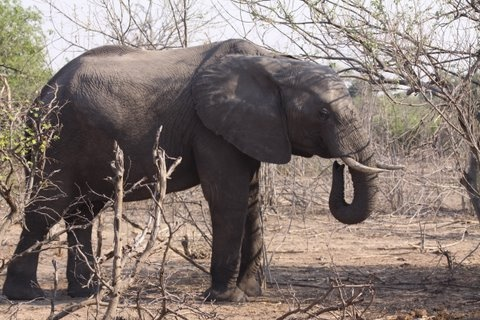Describe the objects in this image and their specific colors. I can see a elephant in beige, black, gray, and darkgray tones in this image. 